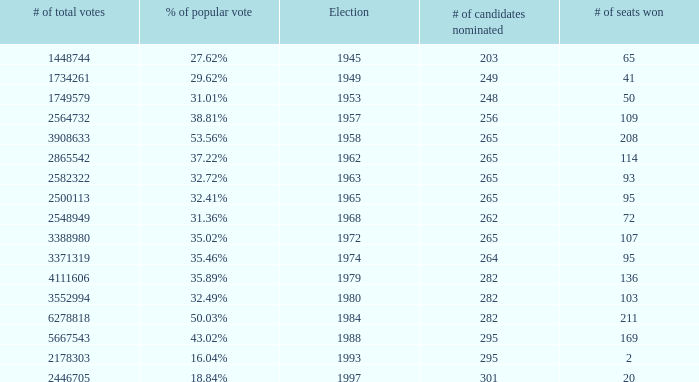What is the election year when the # of candidates nominated was 262? 1.0. 